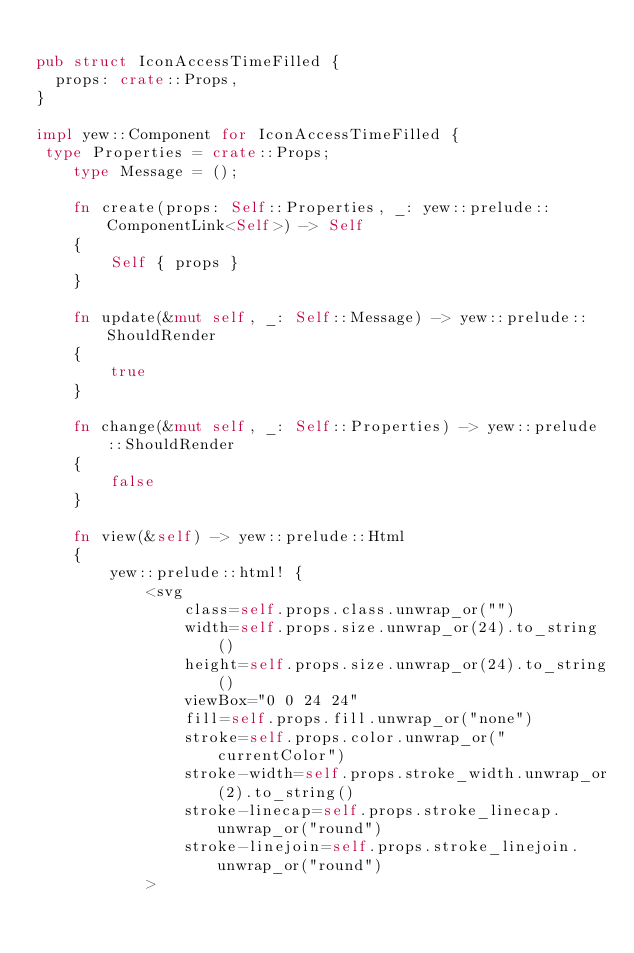<code> <loc_0><loc_0><loc_500><loc_500><_Rust_>
pub struct IconAccessTimeFilled {
  props: crate::Props,
}

impl yew::Component for IconAccessTimeFilled {
 type Properties = crate::Props;
    type Message = ();

    fn create(props: Self::Properties, _: yew::prelude::ComponentLink<Self>) -> Self
    {
        Self { props }
    }

    fn update(&mut self, _: Self::Message) -> yew::prelude::ShouldRender
    {
        true
    }

    fn change(&mut self, _: Self::Properties) -> yew::prelude::ShouldRender
    {
        false
    }

    fn view(&self) -> yew::prelude::Html
    {
        yew::prelude::html! {
            <svg
                class=self.props.class.unwrap_or("")
                width=self.props.size.unwrap_or(24).to_string()
                height=self.props.size.unwrap_or(24).to_string()
                viewBox="0 0 24 24"
                fill=self.props.fill.unwrap_or("none")
                stroke=self.props.color.unwrap_or("currentColor")
                stroke-width=self.props.stroke_width.unwrap_or(2).to_string()
                stroke-linecap=self.props.stroke_linecap.unwrap_or("round")
                stroke-linejoin=self.props.stroke_linejoin.unwrap_or("round")
            ></code> 